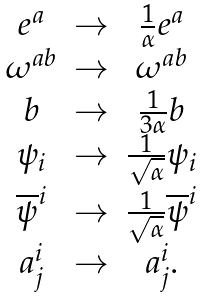Convert formula to latex. <formula><loc_0><loc_0><loc_500><loc_500>\begin{array} { c c c } e ^ { a } & \rightarrow & \frac { 1 } { \alpha } e ^ { a } \\ \omega ^ { a b } & \rightarrow & \omega ^ { a b } \\ b & \rightarrow & \frac { 1 } { 3 \alpha } b \\ \psi _ { i } & \rightarrow & \frac { 1 } { \sqrt { \alpha } } \psi _ { i } \\ \overline { \psi } ^ { i } & \rightarrow & \frac { 1 } { \sqrt { \alpha } } \overline { \psi } ^ { i } \\ a _ { j } ^ { i } & \rightarrow & a _ { j } ^ { i } . \end{array}</formula> 